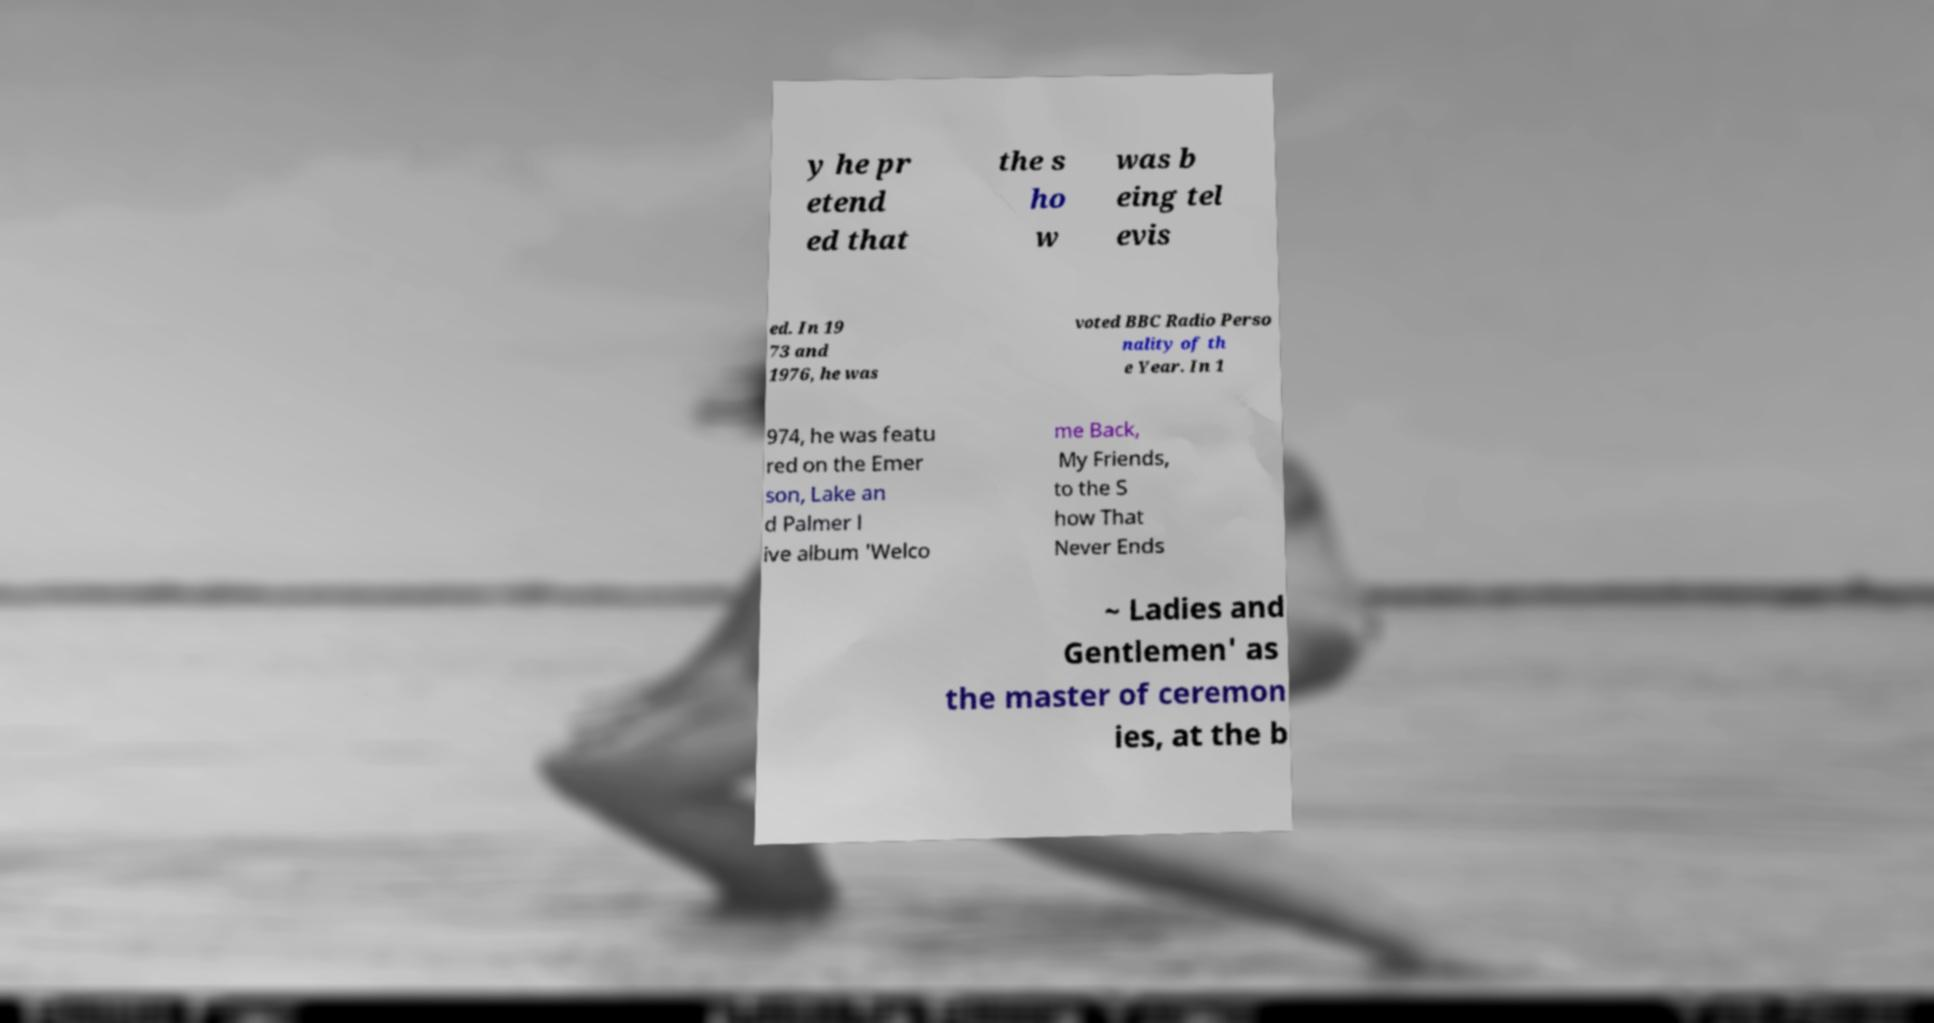Could you extract and type out the text from this image? y he pr etend ed that the s ho w was b eing tel evis ed. In 19 73 and 1976, he was voted BBC Radio Perso nality of th e Year. In 1 974, he was featu red on the Emer son, Lake an d Palmer l ive album 'Welco me Back, My Friends, to the S how That Never Ends ~ Ladies and Gentlemen' as the master of ceremon ies, at the b 